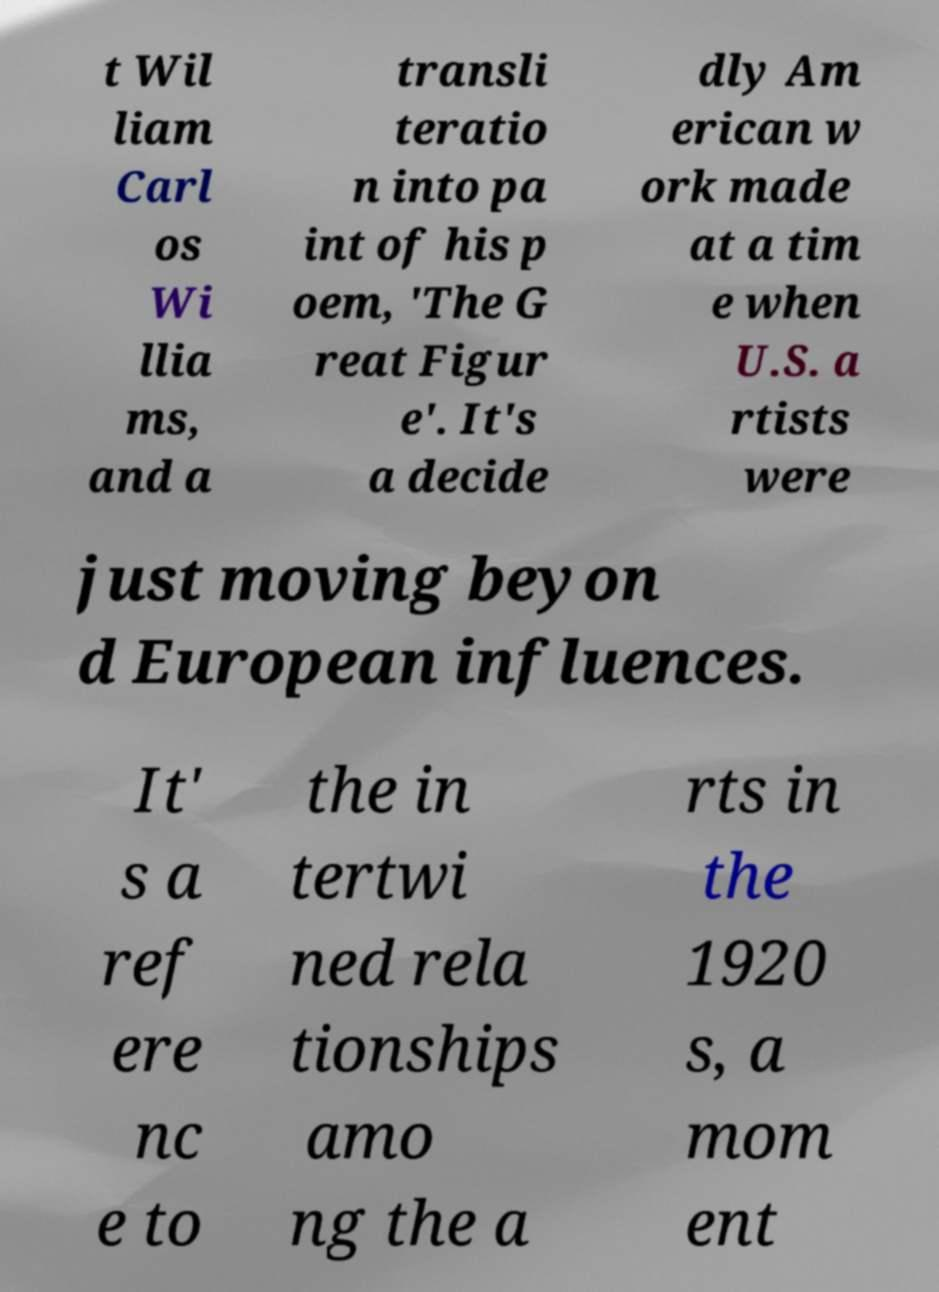Could you extract and type out the text from this image? t Wil liam Carl os Wi llia ms, and a transli teratio n into pa int of his p oem, 'The G reat Figur e'. It's a decide dly Am erican w ork made at a tim e when U.S. a rtists were just moving beyon d European influences. It' s a ref ere nc e to the in tertwi ned rela tionships amo ng the a rts in the 1920 s, a mom ent 